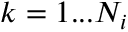Convert formula to latex. <formula><loc_0><loc_0><loc_500><loc_500>k = 1 \dots N _ { i }</formula> 